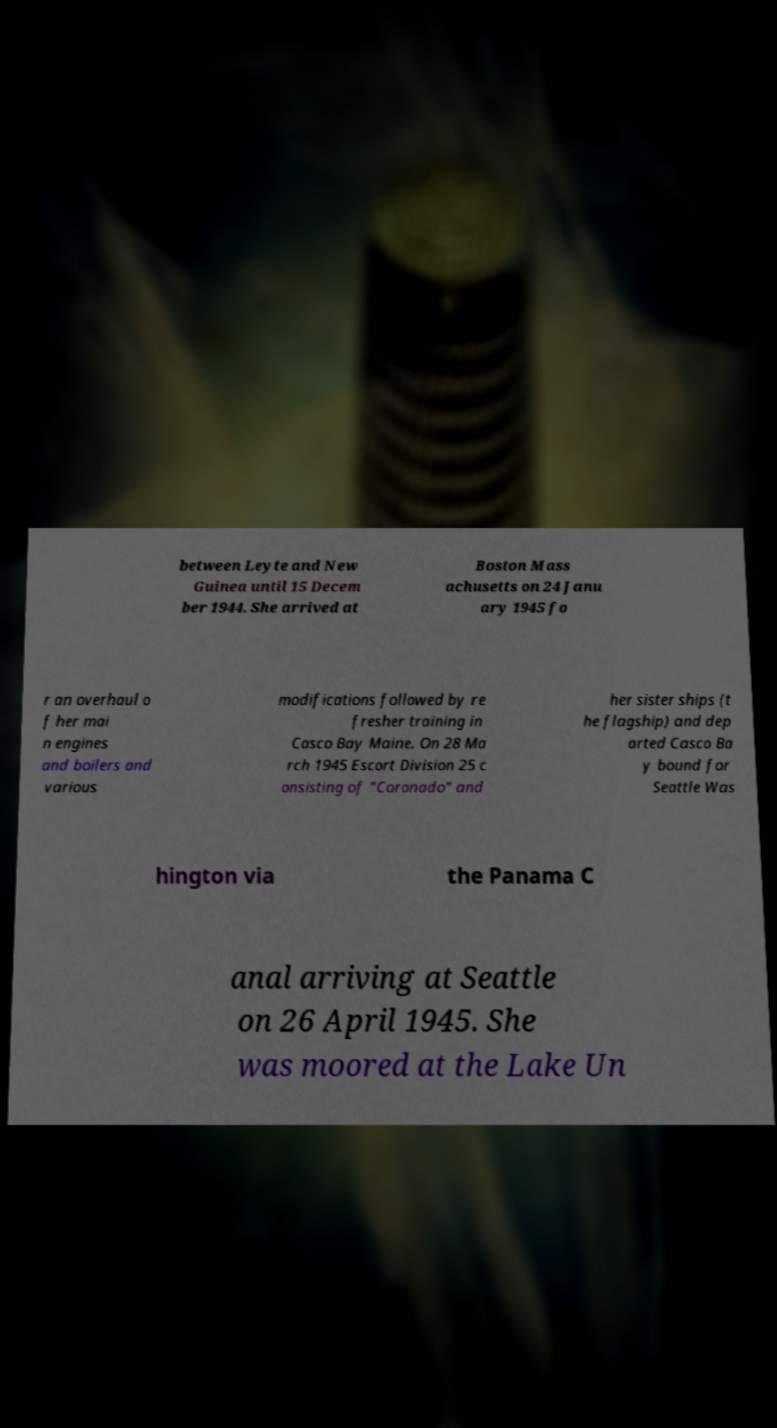Could you extract and type out the text from this image? between Leyte and New Guinea until 15 Decem ber 1944. She arrived at Boston Mass achusetts on 24 Janu ary 1945 fo r an overhaul o f her mai n engines and boilers and various modifications followed by re fresher training in Casco Bay Maine. On 28 Ma rch 1945 Escort Division 25 c onsisting of "Coronado" and her sister ships (t he flagship) and dep arted Casco Ba y bound for Seattle Was hington via the Panama C anal arriving at Seattle on 26 April 1945. She was moored at the Lake Un 